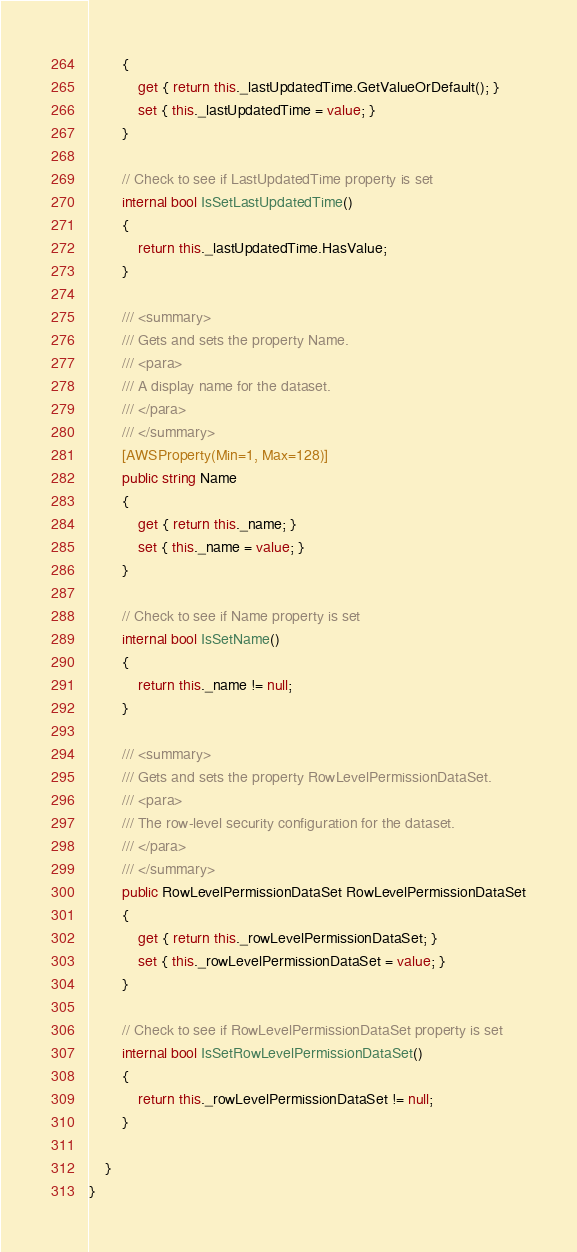<code> <loc_0><loc_0><loc_500><loc_500><_C#_>        {
            get { return this._lastUpdatedTime.GetValueOrDefault(); }
            set { this._lastUpdatedTime = value; }
        }

        // Check to see if LastUpdatedTime property is set
        internal bool IsSetLastUpdatedTime()
        {
            return this._lastUpdatedTime.HasValue; 
        }

        /// <summary>
        /// Gets and sets the property Name. 
        /// <para>
        /// A display name for the dataset.
        /// </para>
        /// </summary>
        [AWSProperty(Min=1, Max=128)]
        public string Name
        {
            get { return this._name; }
            set { this._name = value; }
        }

        // Check to see if Name property is set
        internal bool IsSetName()
        {
            return this._name != null;
        }

        /// <summary>
        /// Gets and sets the property RowLevelPermissionDataSet. 
        /// <para>
        /// The row-level security configuration for the dataset.
        /// </para>
        /// </summary>
        public RowLevelPermissionDataSet RowLevelPermissionDataSet
        {
            get { return this._rowLevelPermissionDataSet; }
            set { this._rowLevelPermissionDataSet = value; }
        }

        // Check to see if RowLevelPermissionDataSet property is set
        internal bool IsSetRowLevelPermissionDataSet()
        {
            return this._rowLevelPermissionDataSet != null;
        }

    }
}</code> 